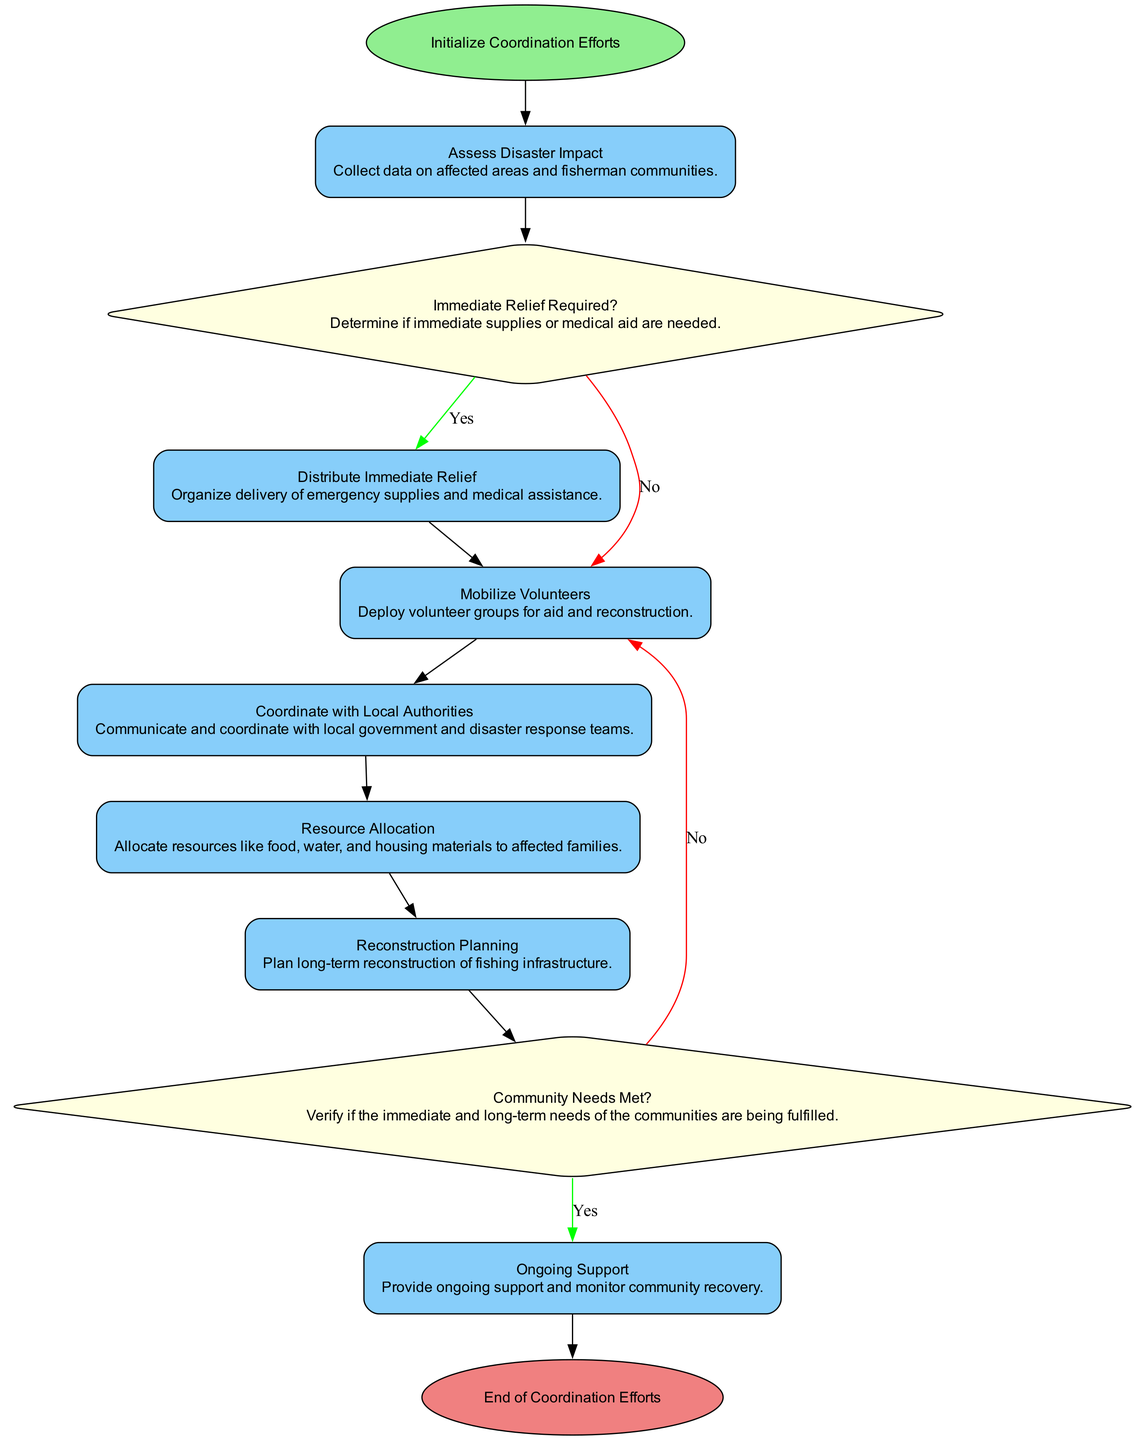What is the starting point of the workflow? The starting point is labeled as "Initialize Coordination Efforts," which is indicated as the first element in the workflow diagram.
Answer: Initialize Coordination Efforts How many total processes are in the workflow? By counting each process type node in the diagram, there are six processes: Assess Disaster Impact, Distribute Immediate Relief, Mobilize Volunteers, Coordinate with Local Authorities, Resource Allocation, and Reconstruction Planning.
Answer: Six What decision is made after assessing disaster impact? The decision made after assessing the impact is whether "Immediate Relief Required?" This is indicated as a decision node immediately following the first process.
Answer: Immediate Relief Required? If immediate relief is required, what is the next step? If immediate relief is required (the "Yes" branch), the next step is "Distribute Immediate Relief," as indicated by the arrow connecting the decision to this process.
Answer: Distribute Immediate Relief What happens if community needs are not met? If community needs are not met (the "No" branch from the decision node "Community Needs Met?"), the process directs back to "Mobilize Volunteers," indicating further efforts need to be made.
Answer: Mobilize Volunteers Which process involves planning for long-term reconstruction? The process responsible for planning long-term reconstruction is labeled "Reconstruction Planning," which is the seventh element of the workflow.
Answer: Reconstruction Planning How many decision nodes are in the workflow? There are two decision nodes in the workflow: "Immediate Relief Required?" and "Community Needs Met?" These can be identified by their diamond shape and the nature of their questions.
Answer: Two What is the final outcome in the workflow? The final outcome of the workflow is labeled as "End of Coordination Efforts," and it's connected to the last process indicating the end of all coordination activities.
Answer: End of Coordination Efforts Which two processes follow the "Mobilize Volunteers" node? The two processes that follow "Mobilize Volunteers" are "Coordinate with Local Authorities" and "Resource Allocation," sequentially indicating the steps for effective volunteer deployment.
Answer: Coordinate with Local Authorities, Resource Allocation 